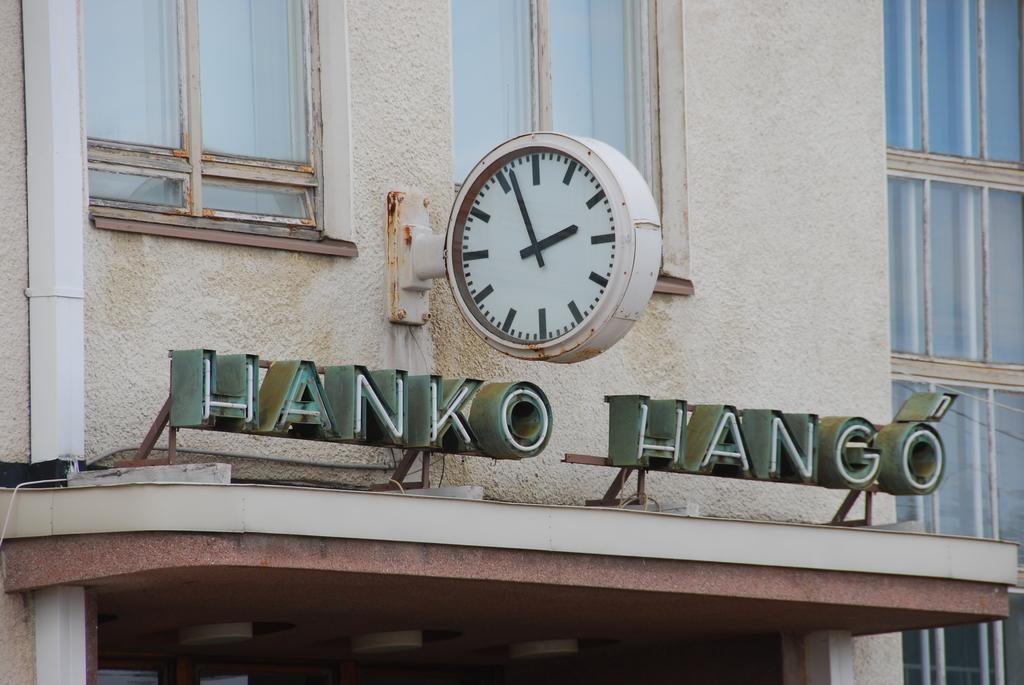<image>
Describe the image concisely. A clock hangs over a sign on a rusted, battered building reading Hanko Hango. 